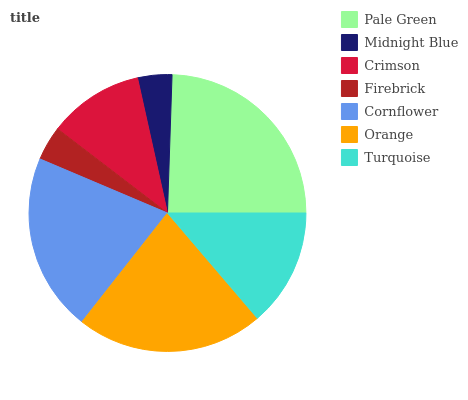Is Midnight Blue the minimum?
Answer yes or no. Yes. Is Pale Green the maximum?
Answer yes or no. Yes. Is Crimson the minimum?
Answer yes or no. No. Is Crimson the maximum?
Answer yes or no. No. Is Crimson greater than Midnight Blue?
Answer yes or no. Yes. Is Midnight Blue less than Crimson?
Answer yes or no. Yes. Is Midnight Blue greater than Crimson?
Answer yes or no. No. Is Crimson less than Midnight Blue?
Answer yes or no. No. Is Turquoise the high median?
Answer yes or no. Yes. Is Turquoise the low median?
Answer yes or no. Yes. Is Cornflower the high median?
Answer yes or no. No. Is Cornflower the low median?
Answer yes or no. No. 